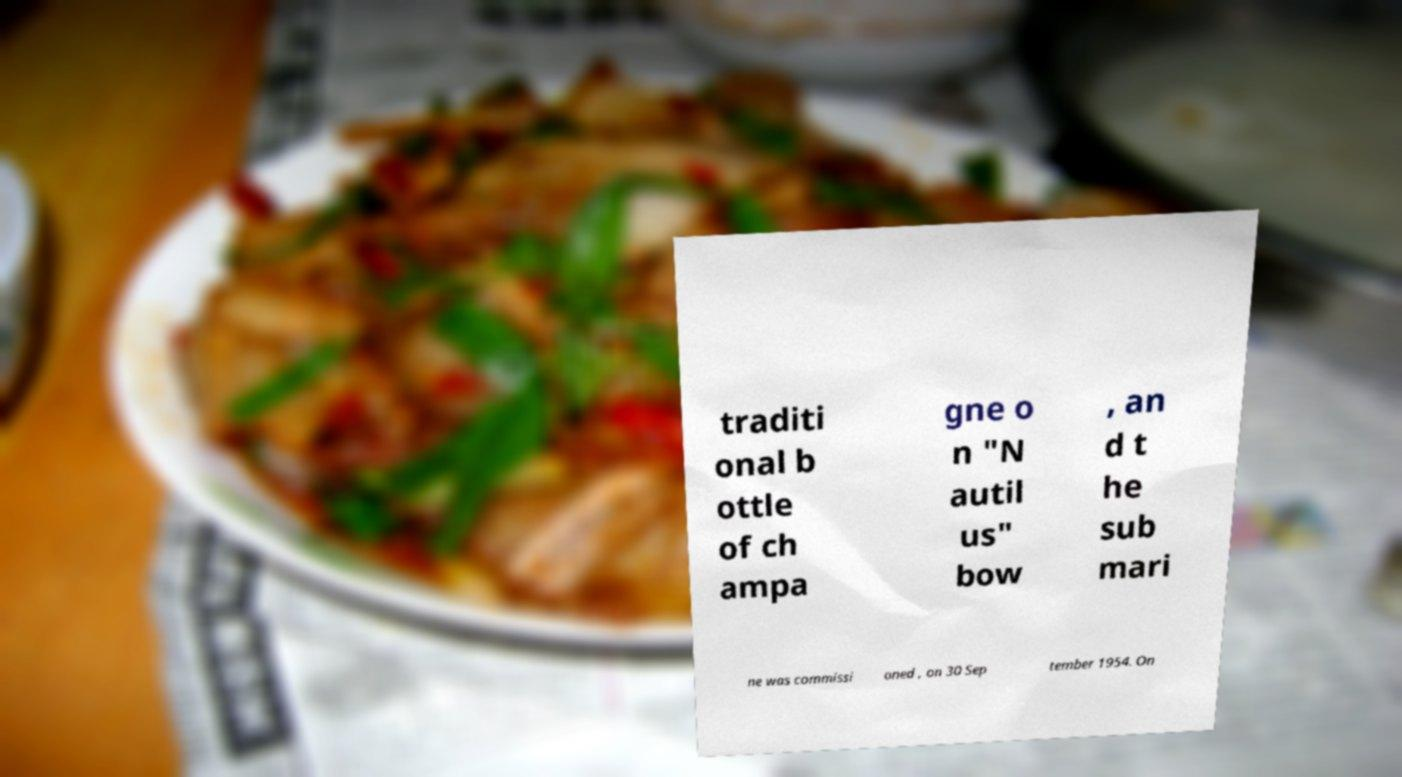Could you extract and type out the text from this image? traditi onal b ottle of ch ampa gne o n "N autil us" bow , an d t he sub mari ne was commissi oned , on 30 Sep tember 1954. On 